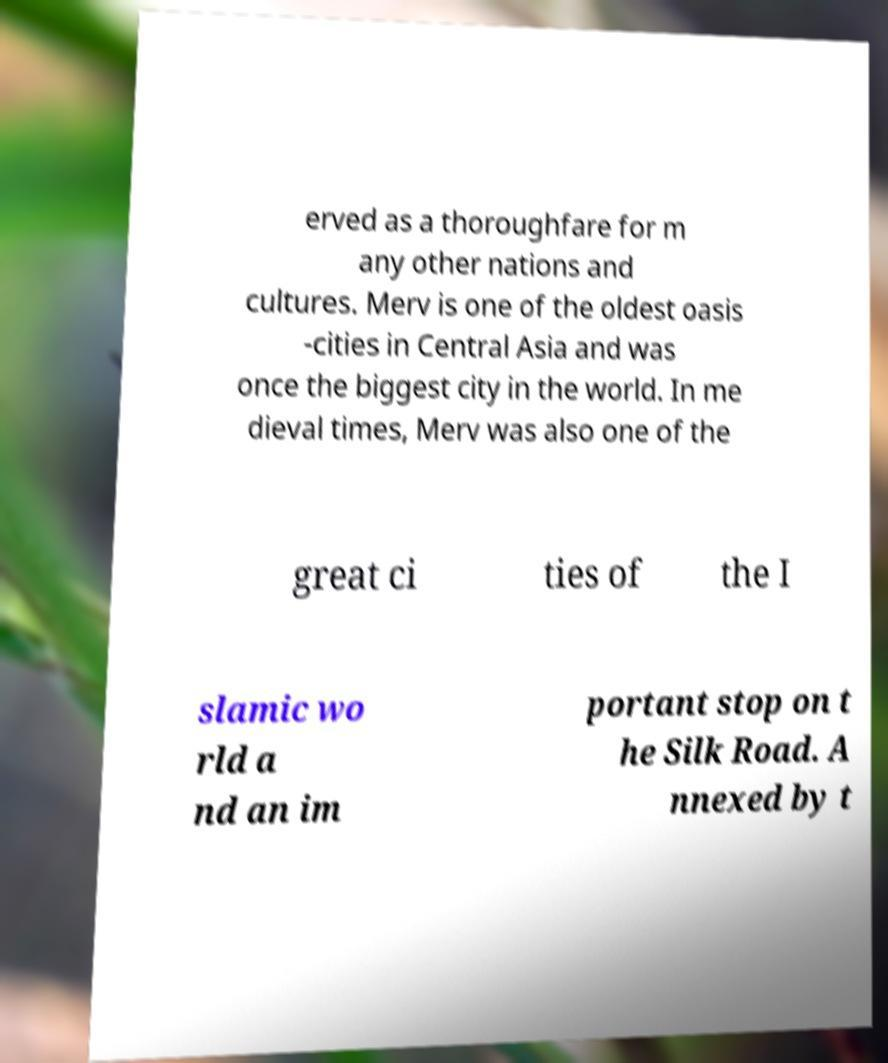What messages or text are displayed in this image? I need them in a readable, typed format. erved as a thoroughfare for m any other nations and cultures. Merv is one of the oldest oasis -cities in Central Asia and was once the biggest city in the world. In me dieval times, Merv was also one of the great ci ties of the I slamic wo rld a nd an im portant stop on t he Silk Road. A nnexed by t 